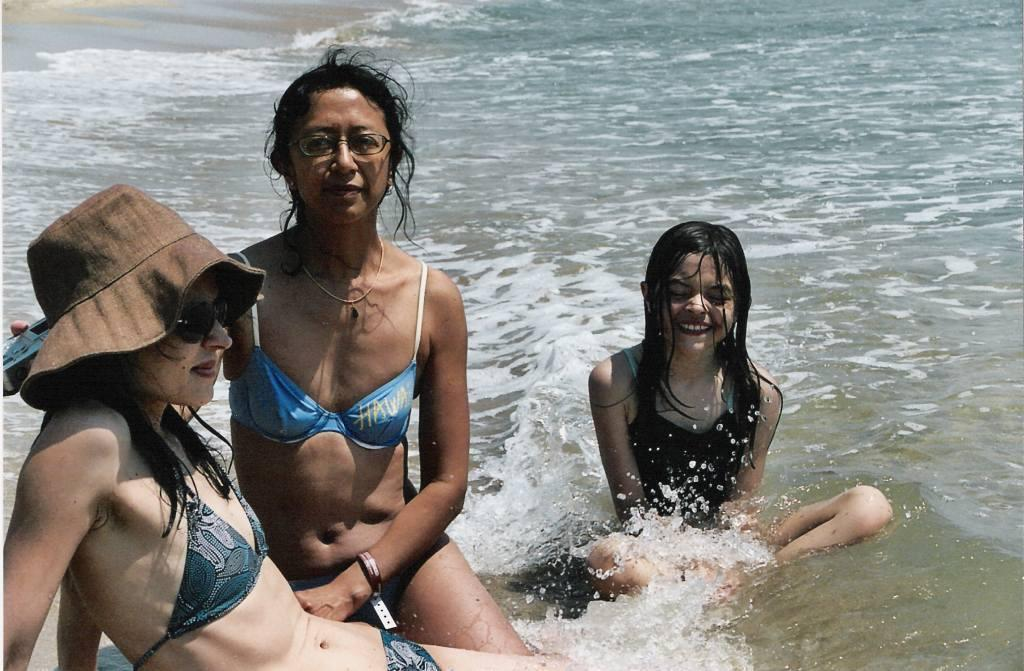What are the people in the image doing? The people in the image are sitting on the ground. What can be seen in the background of the image? There is water visible in the image. What type of art can be seen hanging on the edge of the water in the image? There is no art or edge of the water present in the image; it only features people sitting on the ground and water in the background. 